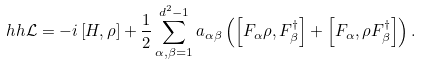Convert formula to latex. <formula><loc_0><loc_0><loc_500><loc_500>\ h h { \mathcal { L } } = - i \left [ H , \rho \right ] + \frac { 1 } { 2 } \sum _ { \alpha , \beta = 1 } ^ { d ^ { 2 } - 1 } a _ { \alpha \beta } \left ( \left [ F _ { \alpha } \rho , F _ { \beta } ^ { \dag } \right ] + \left [ F _ { \alpha } , \rho F _ { \beta } ^ { \dag } \right ] \right ) .</formula> 